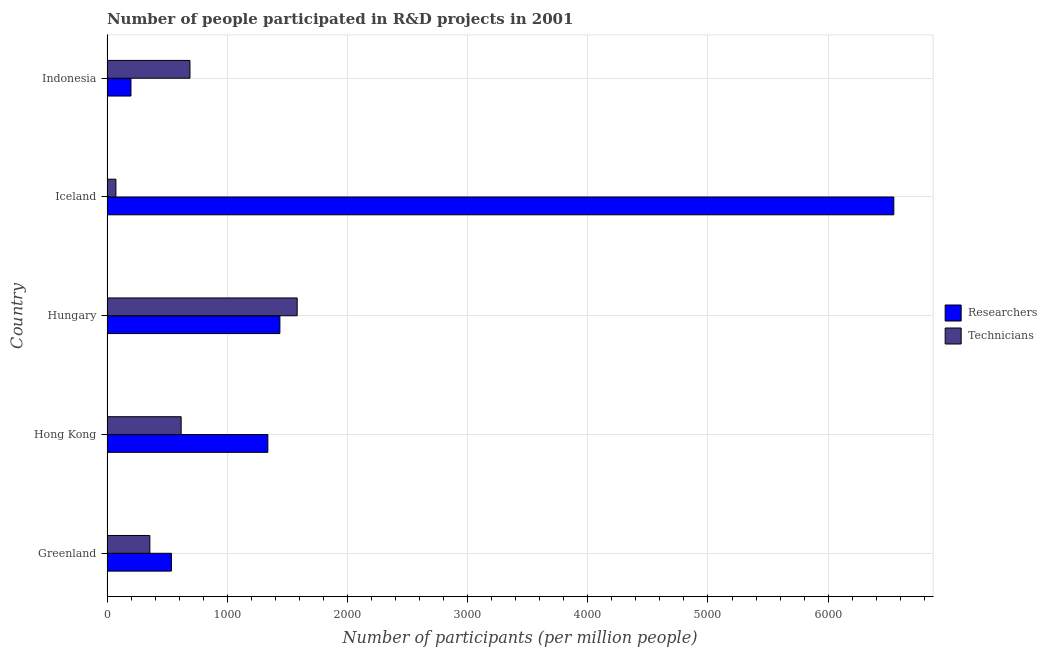How many different coloured bars are there?
Make the answer very short. 2. How many bars are there on the 1st tick from the top?
Your answer should be compact. 2. What is the label of the 4th group of bars from the top?
Make the answer very short. Hong Kong. In how many cases, is the number of bars for a given country not equal to the number of legend labels?
Keep it short and to the point. 0. What is the number of researchers in Hong Kong?
Make the answer very short. 1338.25. Across all countries, what is the maximum number of technicians?
Your response must be concise. 1582.27. Across all countries, what is the minimum number of technicians?
Give a very brief answer. 74.03. In which country was the number of technicians maximum?
Make the answer very short. Hungary. What is the total number of researchers in the graph?
Your answer should be very brief. 1.01e+04. What is the difference between the number of researchers in Greenland and that in Hong Kong?
Ensure brevity in your answer.  -802.19. What is the difference between the number of technicians in Hungary and the number of researchers in Hong Kong?
Your answer should be very brief. 244.02. What is the average number of technicians per country?
Provide a short and direct response. 664.03. What is the difference between the number of researchers and number of technicians in Hungary?
Make the answer very short. -143.86. In how many countries, is the number of technicians greater than 200 ?
Provide a short and direct response. 4. What is the ratio of the number of technicians in Hong Kong to that in Hungary?
Your response must be concise. 0.39. What is the difference between the highest and the second highest number of technicians?
Give a very brief answer. 892. What is the difference between the highest and the lowest number of researchers?
Your answer should be compact. 6347.11. Is the sum of the number of researchers in Greenland and Hong Kong greater than the maximum number of technicians across all countries?
Make the answer very short. Yes. What does the 1st bar from the top in Hong Kong represents?
Make the answer very short. Technicians. What does the 2nd bar from the bottom in Hong Kong represents?
Your answer should be compact. Technicians. How many bars are there?
Ensure brevity in your answer.  10. Are all the bars in the graph horizontal?
Keep it short and to the point. Yes. What is the difference between two consecutive major ticks on the X-axis?
Your answer should be very brief. 1000. Are the values on the major ticks of X-axis written in scientific E-notation?
Your answer should be very brief. No. Does the graph contain any zero values?
Your response must be concise. No. Does the graph contain grids?
Ensure brevity in your answer.  Yes. How are the legend labels stacked?
Your answer should be compact. Vertical. What is the title of the graph?
Make the answer very short. Number of people participated in R&D projects in 2001. What is the label or title of the X-axis?
Provide a succinct answer. Number of participants (per million people). What is the Number of participants (per million people) in Researchers in Greenland?
Ensure brevity in your answer.  536.06. What is the Number of participants (per million people) of Technicians in Greenland?
Your answer should be very brief. 356.63. What is the Number of participants (per million people) of Researchers in Hong Kong?
Keep it short and to the point. 1338.25. What is the Number of participants (per million people) of Technicians in Hong Kong?
Your response must be concise. 616.94. What is the Number of participants (per million people) in Researchers in Hungary?
Give a very brief answer. 1438.41. What is the Number of participants (per million people) of Technicians in Hungary?
Your response must be concise. 1582.27. What is the Number of participants (per million people) of Researchers in Iceland?
Provide a short and direct response. 6546.33. What is the Number of participants (per million people) of Technicians in Iceland?
Your answer should be very brief. 74.03. What is the Number of participants (per million people) of Researchers in Indonesia?
Make the answer very short. 199.22. What is the Number of participants (per million people) in Technicians in Indonesia?
Give a very brief answer. 690.27. Across all countries, what is the maximum Number of participants (per million people) of Researchers?
Ensure brevity in your answer.  6546.33. Across all countries, what is the maximum Number of participants (per million people) of Technicians?
Offer a terse response. 1582.27. Across all countries, what is the minimum Number of participants (per million people) in Researchers?
Provide a short and direct response. 199.22. Across all countries, what is the minimum Number of participants (per million people) in Technicians?
Keep it short and to the point. 74.03. What is the total Number of participants (per million people) of Researchers in the graph?
Keep it short and to the point. 1.01e+04. What is the total Number of participants (per million people) in Technicians in the graph?
Give a very brief answer. 3320.13. What is the difference between the Number of participants (per million people) of Researchers in Greenland and that in Hong Kong?
Keep it short and to the point. -802.19. What is the difference between the Number of participants (per million people) of Technicians in Greenland and that in Hong Kong?
Ensure brevity in your answer.  -260.32. What is the difference between the Number of participants (per million people) in Researchers in Greenland and that in Hungary?
Make the answer very short. -902.35. What is the difference between the Number of participants (per million people) of Technicians in Greenland and that in Hungary?
Your answer should be compact. -1225.64. What is the difference between the Number of participants (per million people) of Researchers in Greenland and that in Iceland?
Your answer should be very brief. -6010.27. What is the difference between the Number of participants (per million people) in Technicians in Greenland and that in Iceland?
Provide a short and direct response. 282.6. What is the difference between the Number of participants (per million people) of Researchers in Greenland and that in Indonesia?
Keep it short and to the point. 336.84. What is the difference between the Number of participants (per million people) of Technicians in Greenland and that in Indonesia?
Your answer should be compact. -333.64. What is the difference between the Number of participants (per million people) of Researchers in Hong Kong and that in Hungary?
Offer a terse response. -100.16. What is the difference between the Number of participants (per million people) of Technicians in Hong Kong and that in Hungary?
Offer a terse response. -965.32. What is the difference between the Number of participants (per million people) of Researchers in Hong Kong and that in Iceland?
Give a very brief answer. -5208.08. What is the difference between the Number of participants (per million people) in Technicians in Hong Kong and that in Iceland?
Offer a terse response. 542.92. What is the difference between the Number of participants (per million people) of Researchers in Hong Kong and that in Indonesia?
Ensure brevity in your answer.  1139.03. What is the difference between the Number of participants (per million people) in Technicians in Hong Kong and that in Indonesia?
Your answer should be compact. -73.32. What is the difference between the Number of participants (per million people) in Researchers in Hungary and that in Iceland?
Offer a terse response. -5107.92. What is the difference between the Number of participants (per million people) of Technicians in Hungary and that in Iceland?
Ensure brevity in your answer.  1508.24. What is the difference between the Number of participants (per million people) of Researchers in Hungary and that in Indonesia?
Your answer should be compact. 1239.19. What is the difference between the Number of participants (per million people) of Technicians in Hungary and that in Indonesia?
Your answer should be very brief. 892. What is the difference between the Number of participants (per million people) in Researchers in Iceland and that in Indonesia?
Make the answer very short. 6347.11. What is the difference between the Number of participants (per million people) in Technicians in Iceland and that in Indonesia?
Make the answer very short. -616.24. What is the difference between the Number of participants (per million people) in Researchers in Greenland and the Number of participants (per million people) in Technicians in Hong Kong?
Ensure brevity in your answer.  -80.88. What is the difference between the Number of participants (per million people) of Researchers in Greenland and the Number of participants (per million people) of Technicians in Hungary?
Your answer should be very brief. -1046.21. What is the difference between the Number of participants (per million people) of Researchers in Greenland and the Number of participants (per million people) of Technicians in Iceland?
Offer a terse response. 462.03. What is the difference between the Number of participants (per million people) of Researchers in Greenland and the Number of participants (per million people) of Technicians in Indonesia?
Provide a short and direct response. -154.21. What is the difference between the Number of participants (per million people) of Researchers in Hong Kong and the Number of participants (per million people) of Technicians in Hungary?
Offer a terse response. -244.02. What is the difference between the Number of participants (per million people) of Researchers in Hong Kong and the Number of participants (per million people) of Technicians in Iceland?
Offer a terse response. 1264.23. What is the difference between the Number of participants (per million people) in Researchers in Hong Kong and the Number of participants (per million people) in Technicians in Indonesia?
Provide a short and direct response. 647.99. What is the difference between the Number of participants (per million people) of Researchers in Hungary and the Number of participants (per million people) of Technicians in Iceland?
Provide a succinct answer. 1364.39. What is the difference between the Number of participants (per million people) in Researchers in Hungary and the Number of participants (per million people) in Technicians in Indonesia?
Make the answer very short. 748.14. What is the difference between the Number of participants (per million people) of Researchers in Iceland and the Number of participants (per million people) of Technicians in Indonesia?
Keep it short and to the point. 5856.06. What is the average Number of participants (per million people) of Researchers per country?
Offer a terse response. 2011.65. What is the average Number of participants (per million people) of Technicians per country?
Your answer should be very brief. 664.03. What is the difference between the Number of participants (per million people) of Researchers and Number of participants (per million people) of Technicians in Greenland?
Offer a terse response. 179.43. What is the difference between the Number of participants (per million people) in Researchers and Number of participants (per million people) in Technicians in Hong Kong?
Your response must be concise. 721.31. What is the difference between the Number of participants (per million people) in Researchers and Number of participants (per million people) in Technicians in Hungary?
Provide a short and direct response. -143.86. What is the difference between the Number of participants (per million people) of Researchers and Number of participants (per million people) of Technicians in Iceland?
Provide a short and direct response. 6472.31. What is the difference between the Number of participants (per million people) in Researchers and Number of participants (per million people) in Technicians in Indonesia?
Provide a succinct answer. -491.05. What is the ratio of the Number of participants (per million people) of Researchers in Greenland to that in Hong Kong?
Your answer should be compact. 0.4. What is the ratio of the Number of participants (per million people) of Technicians in Greenland to that in Hong Kong?
Make the answer very short. 0.58. What is the ratio of the Number of participants (per million people) of Researchers in Greenland to that in Hungary?
Your answer should be compact. 0.37. What is the ratio of the Number of participants (per million people) in Technicians in Greenland to that in Hungary?
Keep it short and to the point. 0.23. What is the ratio of the Number of participants (per million people) of Researchers in Greenland to that in Iceland?
Offer a terse response. 0.08. What is the ratio of the Number of participants (per million people) of Technicians in Greenland to that in Iceland?
Your answer should be very brief. 4.82. What is the ratio of the Number of participants (per million people) of Researchers in Greenland to that in Indonesia?
Offer a very short reply. 2.69. What is the ratio of the Number of participants (per million people) in Technicians in Greenland to that in Indonesia?
Your answer should be compact. 0.52. What is the ratio of the Number of participants (per million people) of Researchers in Hong Kong to that in Hungary?
Your response must be concise. 0.93. What is the ratio of the Number of participants (per million people) of Technicians in Hong Kong to that in Hungary?
Give a very brief answer. 0.39. What is the ratio of the Number of participants (per million people) in Researchers in Hong Kong to that in Iceland?
Your answer should be compact. 0.2. What is the ratio of the Number of participants (per million people) in Technicians in Hong Kong to that in Iceland?
Make the answer very short. 8.33. What is the ratio of the Number of participants (per million people) of Researchers in Hong Kong to that in Indonesia?
Your answer should be compact. 6.72. What is the ratio of the Number of participants (per million people) in Technicians in Hong Kong to that in Indonesia?
Your response must be concise. 0.89. What is the ratio of the Number of participants (per million people) of Researchers in Hungary to that in Iceland?
Your response must be concise. 0.22. What is the ratio of the Number of participants (per million people) of Technicians in Hungary to that in Iceland?
Offer a very short reply. 21.37. What is the ratio of the Number of participants (per million people) of Researchers in Hungary to that in Indonesia?
Give a very brief answer. 7.22. What is the ratio of the Number of participants (per million people) in Technicians in Hungary to that in Indonesia?
Your answer should be compact. 2.29. What is the ratio of the Number of participants (per million people) of Researchers in Iceland to that in Indonesia?
Provide a succinct answer. 32.86. What is the ratio of the Number of participants (per million people) in Technicians in Iceland to that in Indonesia?
Offer a terse response. 0.11. What is the difference between the highest and the second highest Number of participants (per million people) of Researchers?
Make the answer very short. 5107.92. What is the difference between the highest and the second highest Number of participants (per million people) in Technicians?
Your answer should be very brief. 892. What is the difference between the highest and the lowest Number of participants (per million people) in Researchers?
Provide a succinct answer. 6347.11. What is the difference between the highest and the lowest Number of participants (per million people) in Technicians?
Your response must be concise. 1508.24. 